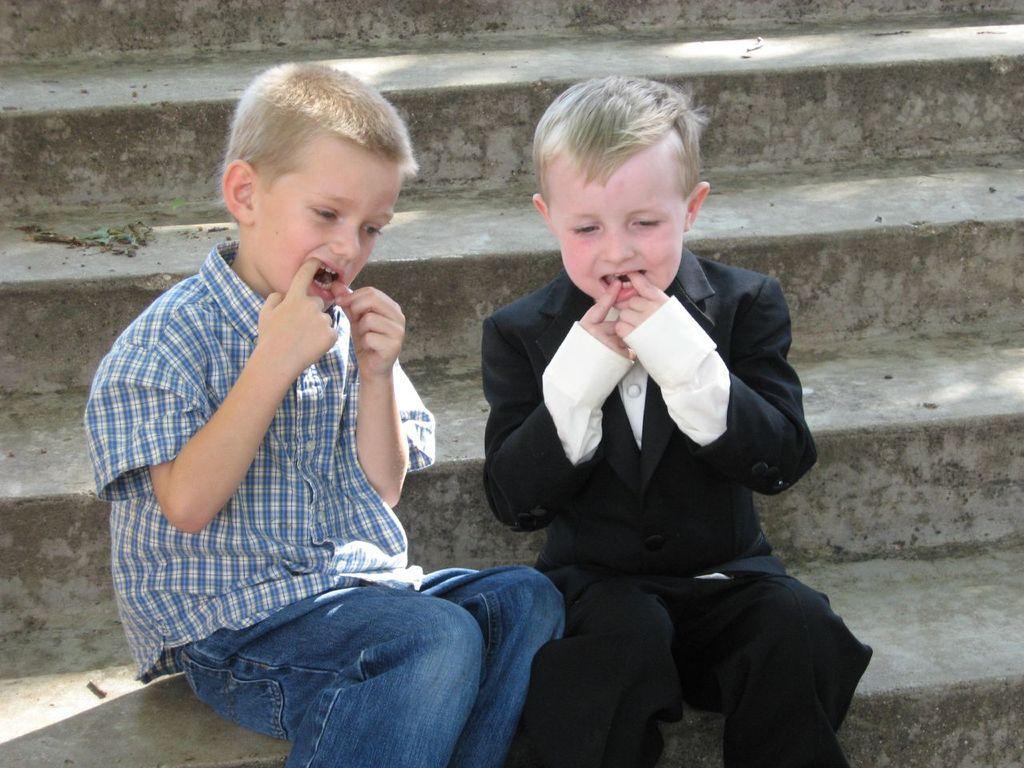How would you summarize this image in a sentence or two? In the image in the center,we can see two kids were sitting. In the background there is a staircase. 